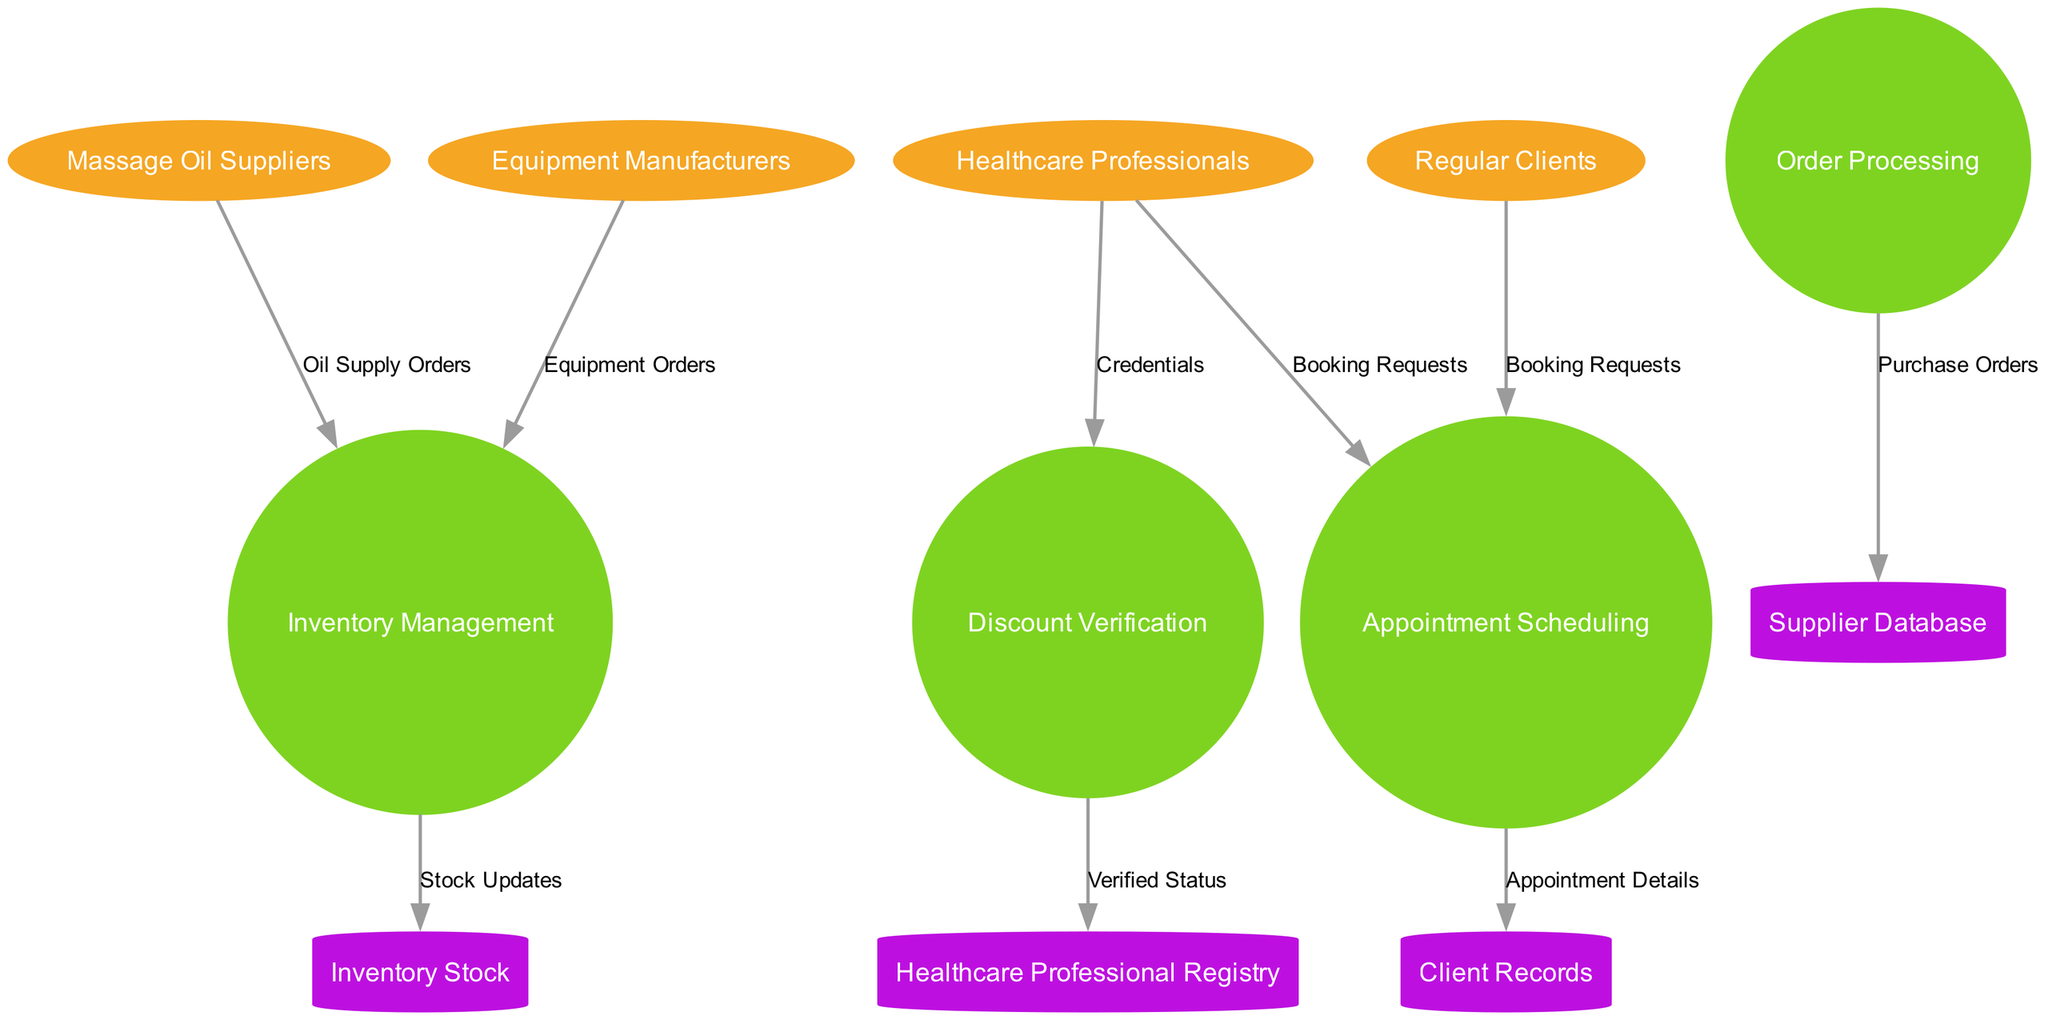What are the external entities in the diagram? The external entities listed in the diagram include "Massage Oil Suppliers", "Equipment Manufacturers", "Healthcare Professionals", and "Regular Clients". These entities represent the sources of input to the system depicted in the data flow diagram.
Answer: Massage Oil Suppliers, Equipment Manufacturers, Healthcare Professionals, Regular Clients How many processes are shown in the diagram? The diagram depicts four processes: "Inventory Management", "Order Processing", "Appointment Scheduling", and "Discount Verification". This indicates that the system involves various operational tasks that manipulate data.
Answer: 4 Which process handles the booking requests from healthcare professionals? The process responsible for handling booking requests from healthcare professionals is "Appointment Scheduling". This process receives requests and manages the appointments accordingly.
Answer: Appointment Scheduling What data store receives appointment details from the appointment scheduling process? The "Client Records" data store receives appointment details from the "Appointment Scheduling" process. This connection indicates that all appointment-related information is stored and managed within client records.
Answer: Client Records From which entity do purchase orders originate in the diagram? Purchase orders originate from the "Order Processing" process, which sends them to the "Supplier Database". This reflects the actions taken to acquire products and supplies necessary for operations.
Answer: Supplier Database How many data flows are depicted in the diagram? The diagram illustrates a total of nine data flows connecting the external entities, processes, and data stores. These flows detail the movement of data throughout the system.
Answer: 9 Which process verifies the credentials of healthcare professionals? The process that verifies the credentials of healthcare professionals is "Discount Verification". This process confirms the eligibility of healthcare professionals for discounts, establishing a connection with the professional registry.
Answer: Discount Verification What input does the inventory management process receive from massage oil suppliers? The input received by the "Inventory Management" process from massage oil suppliers consists of "Oil Supply Orders". This data flow signifies the orders placed for oil supplies necessary for operations.
Answer: Oil Supply Orders Which data store is updated with stock information? The "Inventory Stock" data store is updated with stock information from the "Inventory Management" process. This indicates that the inventory levels are reflected in this data store based on the management process.
Answer: Inventory Stock 